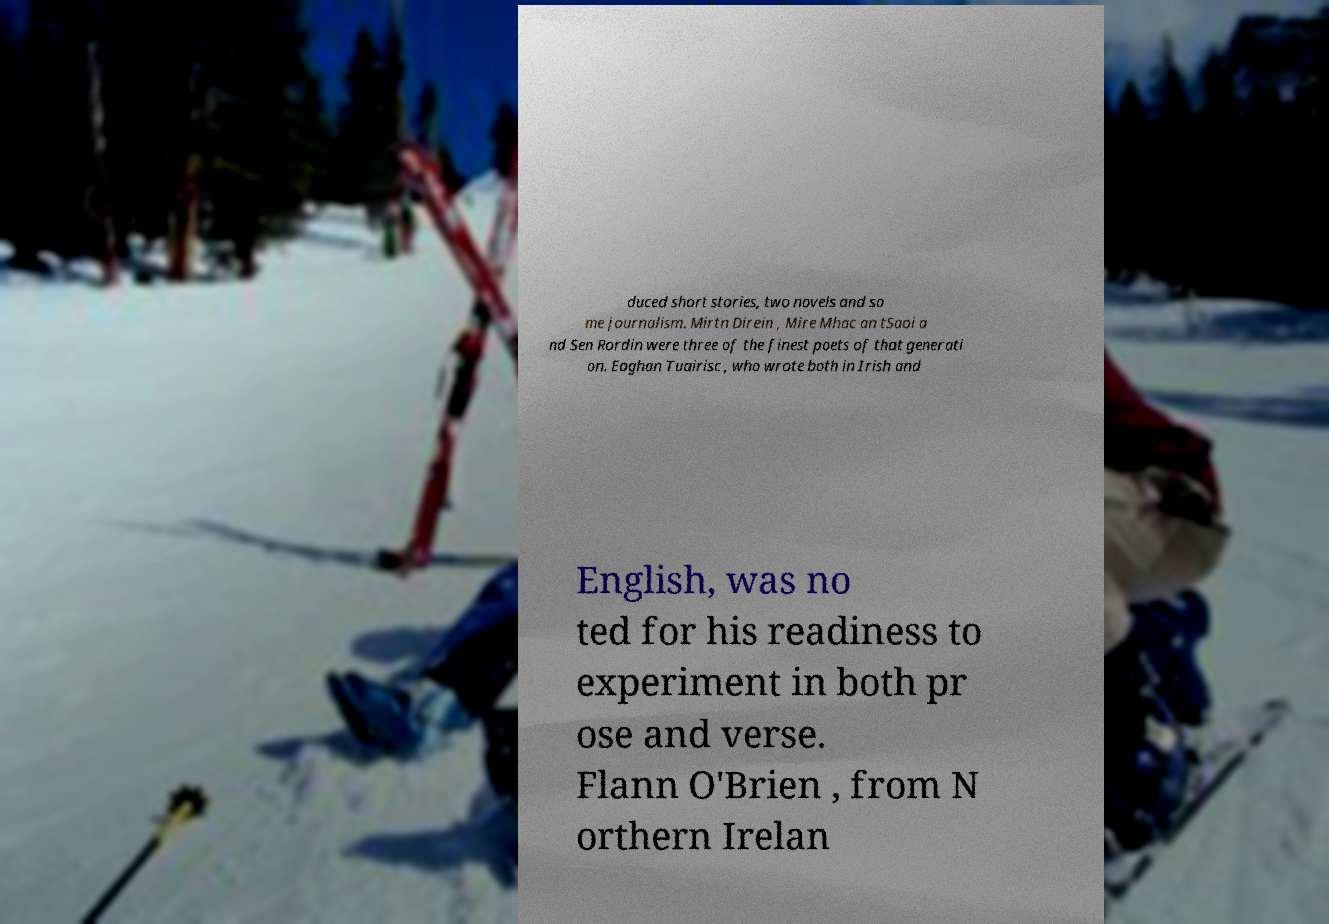There's text embedded in this image that I need extracted. Can you transcribe it verbatim? duced short stories, two novels and so me journalism. Mirtn Direin , Mire Mhac an tSaoi a nd Sen Rordin were three of the finest poets of that generati on. Eoghan Tuairisc , who wrote both in Irish and English, was no ted for his readiness to experiment in both pr ose and verse. Flann O'Brien , from N orthern Irelan 